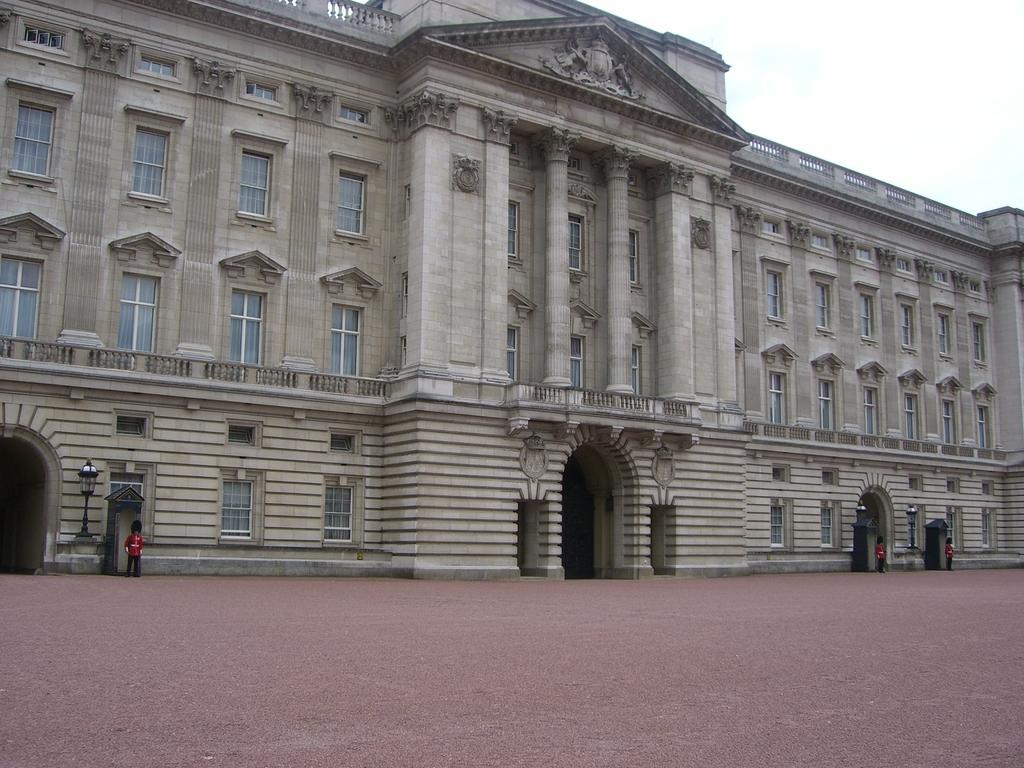Can you describe this image briefly? In this image there is a palace with security guards in front of it. 